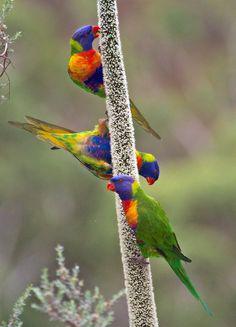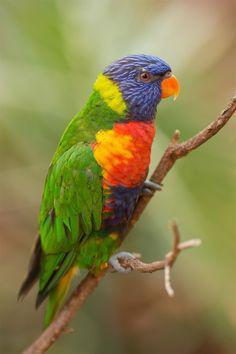The first image is the image on the left, the second image is the image on the right. Given the left and right images, does the statement "There are exactly two birds in the image on the right." hold true? Answer yes or no. No. The first image is the image on the left, the second image is the image on the right. Analyze the images presented: Is the assertion "there is exactly one bird in the image on the left" valid? Answer yes or no. No. The first image is the image on the left, the second image is the image on the right. For the images shown, is this caption "There are no more than three birds" true? Answer yes or no. No. The first image is the image on the left, the second image is the image on the right. Considering the images on both sides, is "In total, the images contain no more than three parrots." valid? Answer yes or no. No. The first image is the image on the left, the second image is the image on the right. Assess this claim about the two images: "There are at most 4 birds shown.". Correct or not? Answer yes or no. Yes. The first image is the image on the left, the second image is the image on the right. Examine the images to the left and right. Is the description "All birds have blue heads and are perched on a branch." accurate? Answer yes or no. Yes. The first image is the image on the left, the second image is the image on the right. Assess this claim about the two images: "Parrots in the right and left images share the same coloration or colorations.". Correct or not? Answer yes or no. Yes. 